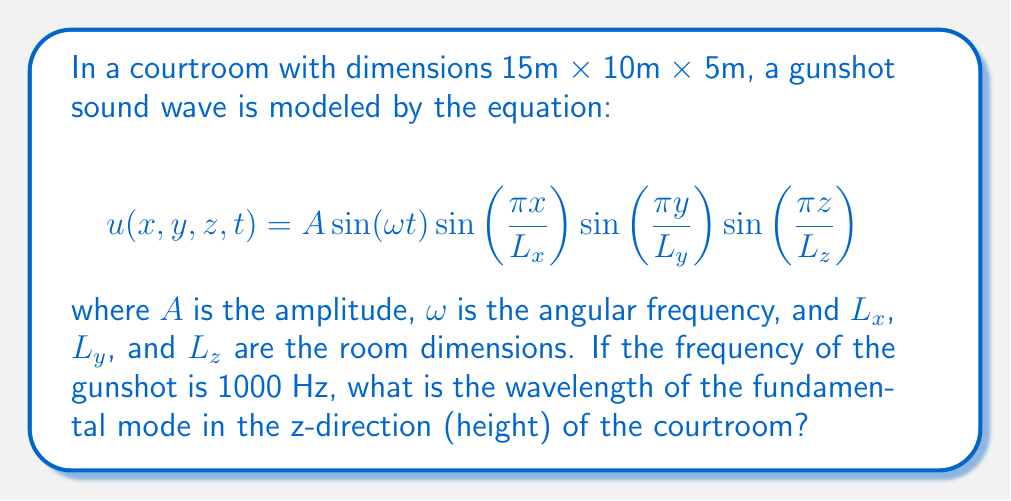Teach me how to tackle this problem. 1) The wave equation in a confined space is given by:

   $$\frac{\partial^2 u}{\partial t^2} = c^2 (\frac{\partial^2 u}{\partial x^2} + \frac{\partial^2 u}{\partial y^2} + \frac{\partial^2 u}{\partial z^2})$$

2) The solution provided in the question satisfies this equation.

3) For the fundamental mode in the z-direction, we have:

   $$k_z = \frac{\pi}{L_z}$$

4) The relationship between wavenumber $k$, frequency $f$, and wavelength $\lambda$ is:

   $$k = \frac{2\pi}{\lambda} = \frac{2\pi f}{c}$$

5) Here, $k_z = \frac{\pi}{L_z} = \frac{2\pi}{\lambda_z}$

6) Therefore, $\lambda_z = 2L_z = 2(5\text{m}) = 10\text{m}$

7) This is the wavelength of the fundamental mode in the z-direction, regardless of the given frequency.

8) To verify if this is physically possible, we can check if it satisfies the wave equation:

   $$c = f\lambda = 1000 \text{ Hz} \cdot 10 \text{ m} = 10,000 \text{ m/s}$$

   This speed is much higher than the speed of sound in air (approximately 343 m/s), indicating that this mode cannot be excited by the gunshot at the given frequency.
Answer: $\lambda_z = 10 \text{ m}$ 